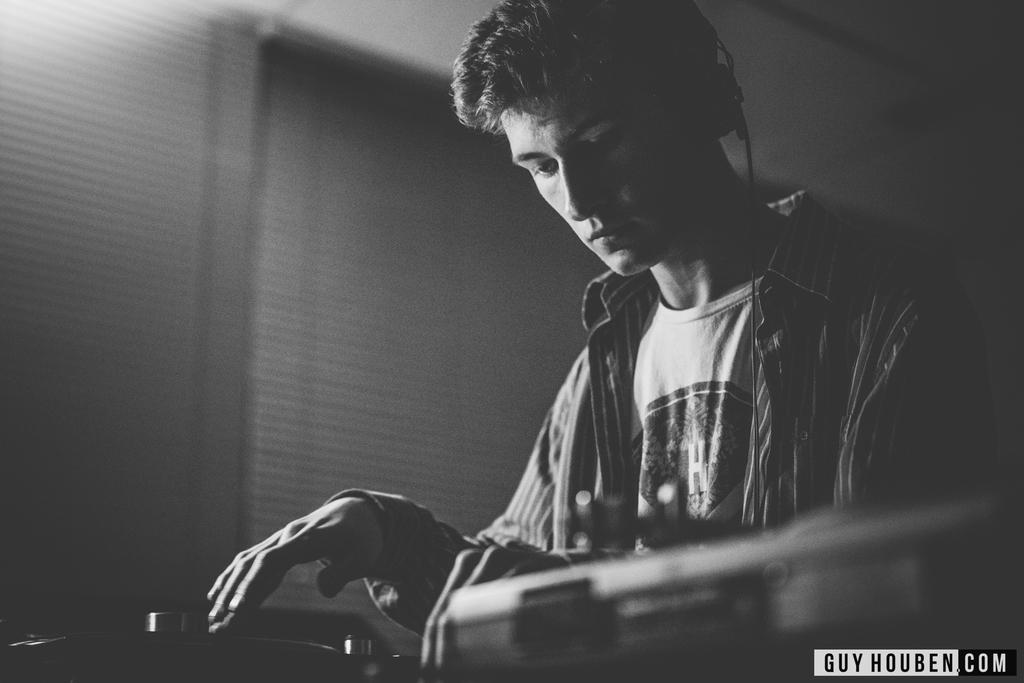What is the main subject in the image? There is a man standing in the image. What is the man standing near? There is a table in the image. What can be seen on the table? There are things placed on the table. What can be seen in the background of the image? There is a wall in the background of the image. What type of sofa is visible in the image? There is no sofa present in the image. How much waste is being generated by the man in the image? There is no indication of waste generation in the image. 